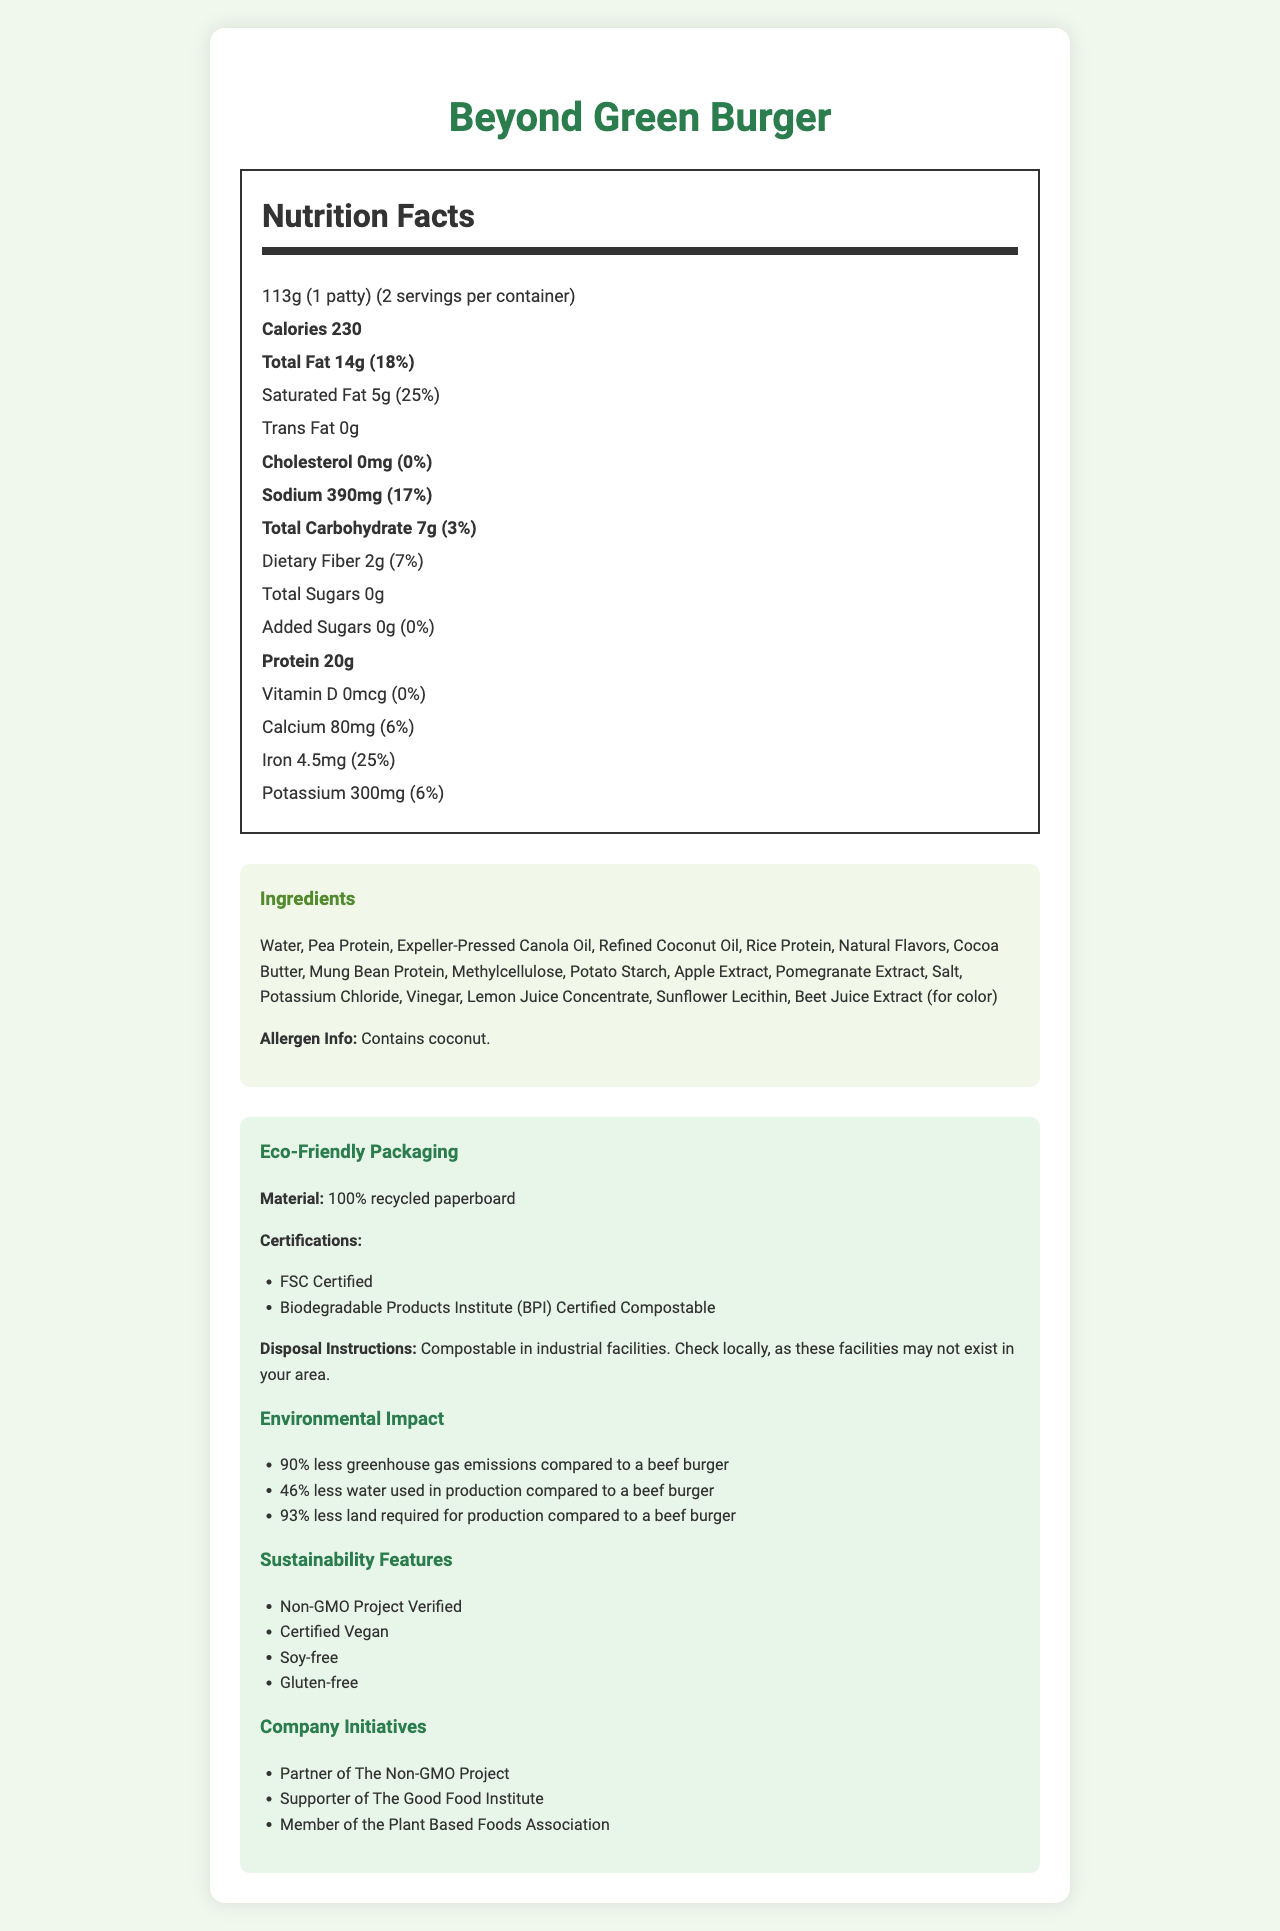what is the serving size of the Beyond Green Burger? The serving size is specified at the top of the Nutrition Facts section.
Answer: 113g (1 patty) how many calories are in one serving of the Beyond Green Burger? The calories per serving are prominently mentioned in the Nutrition Facts section as 230.
Answer: 230 what is the total fat content per serving, and what percentage of the daily value does it represent? The Total Fat content is listed as 14g, which represents 18% of the daily value.
Answer: 14g, 18% does the Beyond Green Burger contain any cholesterol? The cholesterol content is listed as 0mg, which is 0% of the daily value.
Answer: No how much protein does one serving of the Beyond Green Burger provide? The protein content per serving is listed as 20g.
Answer: 20g what is the primary ingredient in the Beyond Green Burger? A. Pea Protein B. Expeller-Pressed Canola Oil C. Water D. Coconut Oil Water is listed as the first ingredient, indicating it's the primary ingredient.
Answer: C. Water what are the sustainability certifications associated with the eco-friendly packaging of the Beyond Green Burger? A. Organic Certified B. FSC Certified C. Biodegradable Products Institute (BPI) Certified Compostable D. Fair Trade Certified The eco-friendly packaging has FSC Certified and Biodegradable Products Institute (BPI) Certified Compostable certifications.
Answer: B, C is the Beyond Green Burger free from added sugars? The Added Sugars content is listed as 0g, which is 0% of the daily value, indicating it has no added sugars.
Answer: Yes describe the packaging material used for the Beyond Green Burger and its disposal instructions. The document states the packaging material is 100% recycled paperboard and the disposal instructions are to compost it in industrial facilities, with a note to check locally as these facilities may not exist in all areas.
Answer: The packaging is made from 100% recycled paperboard and is compostable in industrial facilities. what are three sustainability features of the Beyond Green Burger? The Sustainability Features section lists these specific characteristics.
Answer: Non-GMO Project Verified, Certified Vegan, Soy-free how does the Beyond Green Burger compare to beef burgers in terms of environmental impact? Under the Environmental Impact section, the document details these comparisons.
Answer: The Beyond Green Burger has 90% less greenhouse gas emissions, uses 46% less water, and requires 93% less land. summarize the main information provided in the document about the Beyond Green Burger. The document offers a comprehensive overview of the product, emphasizing nutritional value, environmental benefits, and sustainability certifications.
Answer: The document provides detailed information about the Beyond Green Burger's nutrition facts, ingredients, allergens, sustainability features, eco-friendly packaging, and environmental impact. It highlights that the burger has 230 calories per serving, 20g of protein, 14g of total fat, and contains no cholesterol. The packaging is 100% recycled and compostable, and the burger significantly reduces greenhouse gas emissions, water usage, and land use compared to beef burgers. where is the Beyond Green Burger manufactured? The document does not provide any information about the manufacturing location of the Beyond Green Burger.
Answer: I don't know 